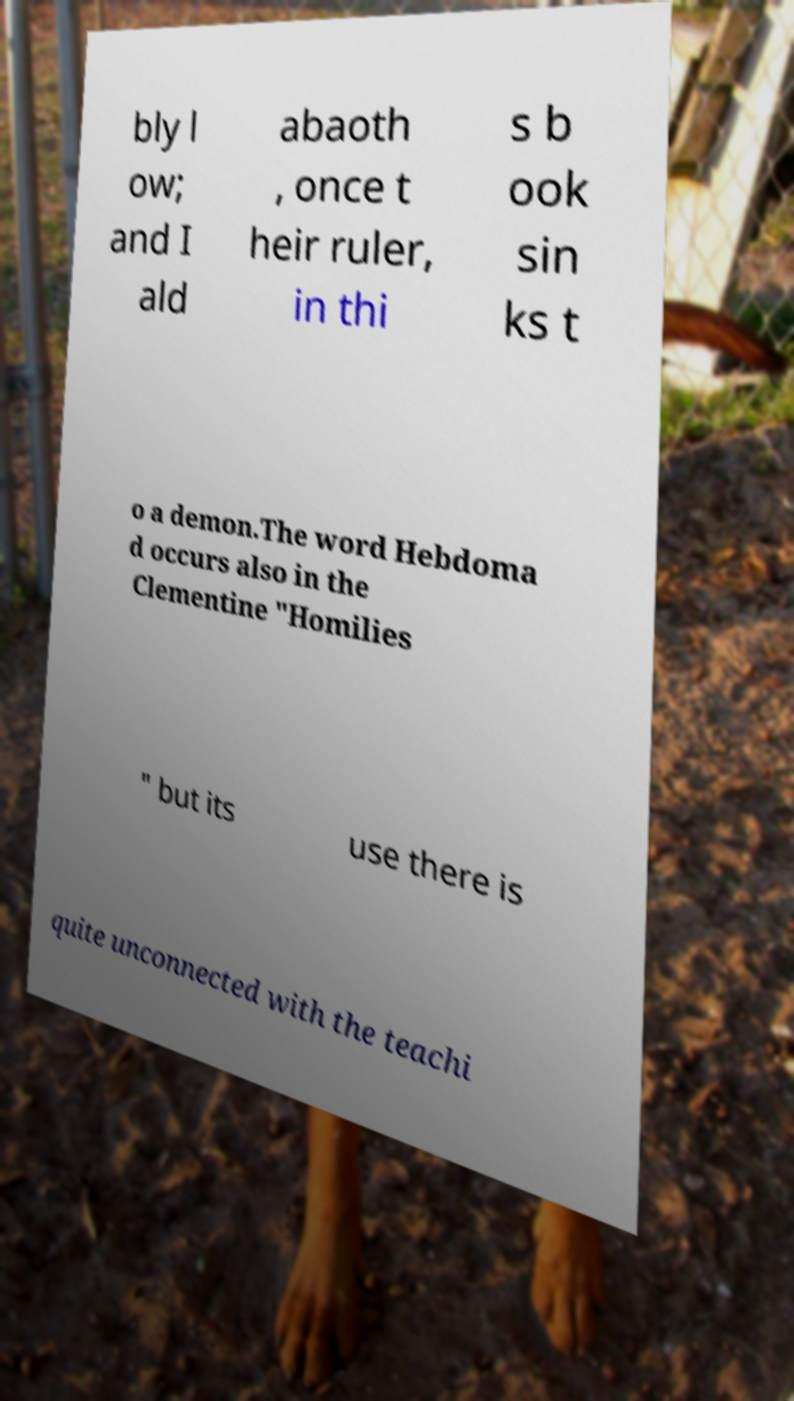I need the written content from this picture converted into text. Can you do that? bly l ow; and I ald abaoth , once t heir ruler, in thi s b ook sin ks t o a demon.The word Hebdoma d occurs also in the Clementine "Homilies " but its use there is quite unconnected with the teachi 